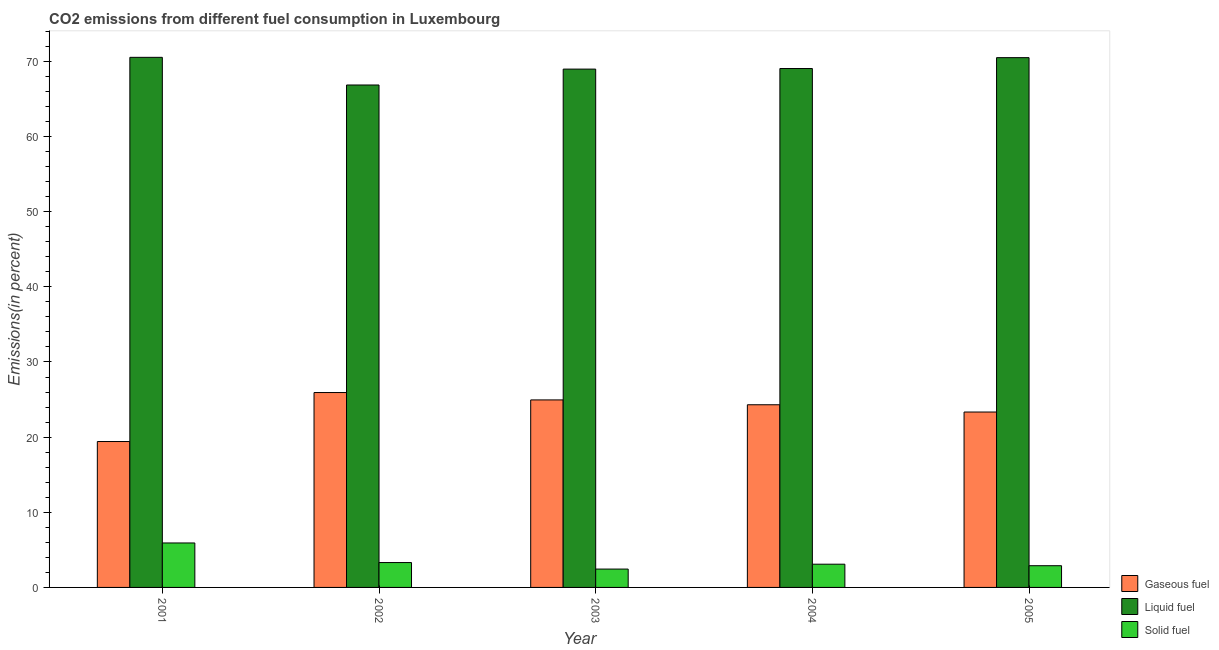Are the number of bars on each tick of the X-axis equal?
Provide a short and direct response. Yes. How many bars are there on the 4th tick from the left?
Offer a terse response. 3. What is the percentage of liquid fuel emission in 2002?
Your answer should be compact. 66.86. Across all years, what is the maximum percentage of solid fuel emission?
Provide a succinct answer. 5.92. Across all years, what is the minimum percentage of liquid fuel emission?
Ensure brevity in your answer.  66.86. In which year was the percentage of solid fuel emission minimum?
Your answer should be very brief. 2003. What is the total percentage of gaseous fuel emission in the graph?
Offer a terse response. 117.95. What is the difference between the percentage of liquid fuel emission in 2001 and that in 2004?
Your answer should be very brief. 1.49. What is the difference between the percentage of liquid fuel emission in 2003 and the percentage of gaseous fuel emission in 2005?
Offer a terse response. -1.52. What is the average percentage of gaseous fuel emission per year?
Keep it short and to the point. 23.59. In the year 2002, what is the difference between the percentage of gaseous fuel emission and percentage of liquid fuel emission?
Your answer should be very brief. 0. In how many years, is the percentage of solid fuel emission greater than 30 %?
Your response must be concise. 0. What is the ratio of the percentage of solid fuel emission in 2001 to that in 2002?
Offer a very short reply. 1.79. Is the difference between the percentage of gaseous fuel emission in 2002 and 2003 greater than the difference between the percentage of liquid fuel emission in 2002 and 2003?
Make the answer very short. No. What is the difference between the highest and the second highest percentage of liquid fuel emission?
Provide a short and direct response. 0.04. What is the difference between the highest and the lowest percentage of liquid fuel emission?
Keep it short and to the point. 3.68. What does the 2nd bar from the left in 2005 represents?
Provide a succinct answer. Liquid fuel. What does the 1st bar from the right in 2004 represents?
Offer a terse response. Solid fuel. How many bars are there?
Your answer should be compact. 15. Are all the bars in the graph horizontal?
Your response must be concise. No. How many years are there in the graph?
Your answer should be very brief. 5. What is the difference between two consecutive major ticks on the Y-axis?
Offer a very short reply. 10. Where does the legend appear in the graph?
Offer a very short reply. Bottom right. What is the title of the graph?
Provide a short and direct response. CO2 emissions from different fuel consumption in Luxembourg. Does "Machinery" appear as one of the legend labels in the graph?
Keep it short and to the point. No. What is the label or title of the X-axis?
Offer a terse response. Year. What is the label or title of the Y-axis?
Provide a succinct answer. Emissions(in percent). What is the Emissions(in percent) in Gaseous fuel in 2001?
Offer a very short reply. 19.42. What is the Emissions(in percent) of Liquid fuel in 2001?
Provide a succinct answer. 70.54. What is the Emissions(in percent) in Solid fuel in 2001?
Keep it short and to the point. 5.92. What is the Emissions(in percent) of Gaseous fuel in 2002?
Ensure brevity in your answer.  25.93. What is the Emissions(in percent) of Liquid fuel in 2002?
Provide a succinct answer. 66.86. What is the Emissions(in percent) of Solid fuel in 2002?
Offer a very short reply. 3.31. What is the Emissions(in percent) in Gaseous fuel in 2003?
Offer a terse response. 24.95. What is the Emissions(in percent) in Liquid fuel in 2003?
Offer a very short reply. 68.97. What is the Emissions(in percent) of Solid fuel in 2003?
Provide a short and direct response. 2.44. What is the Emissions(in percent) in Gaseous fuel in 2004?
Keep it short and to the point. 24.31. What is the Emissions(in percent) in Liquid fuel in 2004?
Offer a very short reply. 69.05. What is the Emissions(in percent) in Solid fuel in 2004?
Your response must be concise. 3.09. What is the Emissions(in percent) of Gaseous fuel in 2005?
Your response must be concise. 23.34. What is the Emissions(in percent) of Liquid fuel in 2005?
Provide a short and direct response. 70.5. What is the Emissions(in percent) of Solid fuel in 2005?
Your answer should be very brief. 2.89. Across all years, what is the maximum Emissions(in percent) of Gaseous fuel?
Keep it short and to the point. 25.93. Across all years, what is the maximum Emissions(in percent) in Liquid fuel?
Your answer should be compact. 70.54. Across all years, what is the maximum Emissions(in percent) of Solid fuel?
Ensure brevity in your answer.  5.92. Across all years, what is the minimum Emissions(in percent) in Gaseous fuel?
Offer a very short reply. 19.42. Across all years, what is the minimum Emissions(in percent) of Liquid fuel?
Make the answer very short. 66.86. Across all years, what is the minimum Emissions(in percent) of Solid fuel?
Give a very brief answer. 2.44. What is the total Emissions(in percent) in Gaseous fuel in the graph?
Offer a terse response. 117.95. What is the total Emissions(in percent) of Liquid fuel in the graph?
Keep it short and to the point. 345.93. What is the total Emissions(in percent) of Solid fuel in the graph?
Your answer should be compact. 17.65. What is the difference between the Emissions(in percent) in Gaseous fuel in 2001 and that in 2002?
Keep it short and to the point. -6.52. What is the difference between the Emissions(in percent) in Liquid fuel in 2001 and that in 2002?
Keep it short and to the point. 3.68. What is the difference between the Emissions(in percent) in Solid fuel in 2001 and that in 2002?
Make the answer very short. 2.61. What is the difference between the Emissions(in percent) of Gaseous fuel in 2001 and that in 2003?
Provide a short and direct response. -5.54. What is the difference between the Emissions(in percent) in Liquid fuel in 2001 and that in 2003?
Provide a short and direct response. 1.57. What is the difference between the Emissions(in percent) of Solid fuel in 2001 and that in 2003?
Give a very brief answer. 3.47. What is the difference between the Emissions(in percent) of Gaseous fuel in 2001 and that in 2004?
Keep it short and to the point. -4.89. What is the difference between the Emissions(in percent) of Liquid fuel in 2001 and that in 2004?
Make the answer very short. 1.49. What is the difference between the Emissions(in percent) in Solid fuel in 2001 and that in 2004?
Give a very brief answer. 2.83. What is the difference between the Emissions(in percent) in Gaseous fuel in 2001 and that in 2005?
Your answer should be very brief. -3.92. What is the difference between the Emissions(in percent) of Liquid fuel in 2001 and that in 2005?
Give a very brief answer. 0.04. What is the difference between the Emissions(in percent) in Solid fuel in 2001 and that in 2005?
Keep it short and to the point. 3.03. What is the difference between the Emissions(in percent) of Gaseous fuel in 2002 and that in 2003?
Provide a short and direct response. 0.98. What is the difference between the Emissions(in percent) of Liquid fuel in 2002 and that in 2003?
Provide a succinct answer. -2.11. What is the difference between the Emissions(in percent) of Solid fuel in 2002 and that in 2003?
Your answer should be compact. 0.87. What is the difference between the Emissions(in percent) of Gaseous fuel in 2002 and that in 2004?
Offer a terse response. 1.63. What is the difference between the Emissions(in percent) of Liquid fuel in 2002 and that in 2004?
Offer a very short reply. -2.19. What is the difference between the Emissions(in percent) of Solid fuel in 2002 and that in 2004?
Your response must be concise. 0.22. What is the difference between the Emissions(in percent) of Gaseous fuel in 2002 and that in 2005?
Provide a succinct answer. 2.59. What is the difference between the Emissions(in percent) in Liquid fuel in 2002 and that in 2005?
Ensure brevity in your answer.  -3.64. What is the difference between the Emissions(in percent) in Solid fuel in 2002 and that in 2005?
Provide a short and direct response. 0.42. What is the difference between the Emissions(in percent) in Gaseous fuel in 2003 and that in 2004?
Offer a terse response. 0.65. What is the difference between the Emissions(in percent) in Liquid fuel in 2003 and that in 2004?
Offer a terse response. -0.08. What is the difference between the Emissions(in percent) in Solid fuel in 2003 and that in 2004?
Your answer should be very brief. -0.65. What is the difference between the Emissions(in percent) of Gaseous fuel in 2003 and that in 2005?
Offer a terse response. 1.61. What is the difference between the Emissions(in percent) of Liquid fuel in 2003 and that in 2005?
Your answer should be compact. -1.52. What is the difference between the Emissions(in percent) in Solid fuel in 2003 and that in 2005?
Your answer should be compact. -0.45. What is the difference between the Emissions(in percent) of Gaseous fuel in 2004 and that in 2005?
Make the answer very short. 0.97. What is the difference between the Emissions(in percent) of Liquid fuel in 2004 and that in 2005?
Your response must be concise. -1.45. What is the difference between the Emissions(in percent) in Solid fuel in 2004 and that in 2005?
Your answer should be compact. 0.2. What is the difference between the Emissions(in percent) of Gaseous fuel in 2001 and the Emissions(in percent) of Liquid fuel in 2002?
Provide a short and direct response. -47.44. What is the difference between the Emissions(in percent) of Gaseous fuel in 2001 and the Emissions(in percent) of Solid fuel in 2002?
Make the answer very short. 16.11. What is the difference between the Emissions(in percent) in Liquid fuel in 2001 and the Emissions(in percent) in Solid fuel in 2002?
Offer a very short reply. 67.23. What is the difference between the Emissions(in percent) in Gaseous fuel in 2001 and the Emissions(in percent) in Liquid fuel in 2003?
Provide a succinct answer. -49.56. What is the difference between the Emissions(in percent) in Gaseous fuel in 2001 and the Emissions(in percent) in Solid fuel in 2003?
Give a very brief answer. 16.97. What is the difference between the Emissions(in percent) in Liquid fuel in 2001 and the Emissions(in percent) in Solid fuel in 2003?
Your answer should be compact. 68.1. What is the difference between the Emissions(in percent) of Gaseous fuel in 2001 and the Emissions(in percent) of Liquid fuel in 2004?
Ensure brevity in your answer.  -49.64. What is the difference between the Emissions(in percent) of Gaseous fuel in 2001 and the Emissions(in percent) of Solid fuel in 2004?
Your response must be concise. 16.33. What is the difference between the Emissions(in percent) of Liquid fuel in 2001 and the Emissions(in percent) of Solid fuel in 2004?
Provide a short and direct response. 67.45. What is the difference between the Emissions(in percent) in Gaseous fuel in 2001 and the Emissions(in percent) in Liquid fuel in 2005?
Give a very brief answer. -51.08. What is the difference between the Emissions(in percent) of Gaseous fuel in 2001 and the Emissions(in percent) of Solid fuel in 2005?
Ensure brevity in your answer.  16.53. What is the difference between the Emissions(in percent) in Liquid fuel in 2001 and the Emissions(in percent) in Solid fuel in 2005?
Make the answer very short. 67.65. What is the difference between the Emissions(in percent) of Gaseous fuel in 2002 and the Emissions(in percent) of Liquid fuel in 2003?
Your answer should be very brief. -43.04. What is the difference between the Emissions(in percent) in Gaseous fuel in 2002 and the Emissions(in percent) in Solid fuel in 2003?
Your answer should be compact. 23.49. What is the difference between the Emissions(in percent) of Liquid fuel in 2002 and the Emissions(in percent) of Solid fuel in 2003?
Offer a terse response. 64.42. What is the difference between the Emissions(in percent) of Gaseous fuel in 2002 and the Emissions(in percent) of Liquid fuel in 2004?
Provide a succinct answer. -43.12. What is the difference between the Emissions(in percent) of Gaseous fuel in 2002 and the Emissions(in percent) of Solid fuel in 2004?
Offer a very short reply. 22.84. What is the difference between the Emissions(in percent) in Liquid fuel in 2002 and the Emissions(in percent) in Solid fuel in 2004?
Give a very brief answer. 63.77. What is the difference between the Emissions(in percent) of Gaseous fuel in 2002 and the Emissions(in percent) of Liquid fuel in 2005?
Your answer should be compact. -44.56. What is the difference between the Emissions(in percent) of Gaseous fuel in 2002 and the Emissions(in percent) of Solid fuel in 2005?
Ensure brevity in your answer.  23.04. What is the difference between the Emissions(in percent) of Liquid fuel in 2002 and the Emissions(in percent) of Solid fuel in 2005?
Provide a short and direct response. 63.97. What is the difference between the Emissions(in percent) of Gaseous fuel in 2003 and the Emissions(in percent) of Liquid fuel in 2004?
Keep it short and to the point. -44.1. What is the difference between the Emissions(in percent) in Gaseous fuel in 2003 and the Emissions(in percent) in Solid fuel in 2004?
Your answer should be compact. 21.86. What is the difference between the Emissions(in percent) in Liquid fuel in 2003 and the Emissions(in percent) in Solid fuel in 2004?
Your response must be concise. 65.88. What is the difference between the Emissions(in percent) in Gaseous fuel in 2003 and the Emissions(in percent) in Liquid fuel in 2005?
Your answer should be very brief. -45.54. What is the difference between the Emissions(in percent) in Gaseous fuel in 2003 and the Emissions(in percent) in Solid fuel in 2005?
Your answer should be very brief. 22.06. What is the difference between the Emissions(in percent) of Liquid fuel in 2003 and the Emissions(in percent) of Solid fuel in 2005?
Keep it short and to the point. 66.08. What is the difference between the Emissions(in percent) of Gaseous fuel in 2004 and the Emissions(in percent) of Liquid fuel in 2005?
Your answer should be very brief. -46.19. What is the difference between the Emissions(in percent) of Gaseous fuel in 2004 and the Emissions(in percent) of Solid fuel in 2005?
Keep it short and to the point. 21.42. What is the difference between the Emissions(in percent) of Liquid fuel in 2004 and the Emissions(in percent) of Solid fuel in 2005?
Keep it short and to the point. 66.16. What is the average Emissions(in percent) of Gaseous fuel per year?
Ensure brevity in your answer.  23.59. What is the average Emissions(in percent) of Liquid fuel per year?
Your answer should be very brief. 69.19. What is the average Emissions(in percent) in Solid fuel per year?
Provide a succinct answer. 3.53. In the year 2001, what is the difference between the Emissions(in percent) in Gaseous fuel and Emissions(in percent) in Liquid fuel?
Keep it short and to the point. -51.12. In the year 2001, what is the difference between the Emissions(in percent) in Liquid fuel and Emissions(in percent) in Solid fuel?
Your answer should be very brief. 64.62. In the year 2002, what is the difference between the Emissions(in percent) in Gaseous fuel and Emissions(in percent) in Liquid fuel?
Ensure brevity in your answer.  -40.93. In the year 2002, what is the difference between the Emissions(in percent) in Gaseous fuel and Emissions(in percent) in Solid fuel?
Your answer should be very brief. 22.62. In the year 2002, what is the difference between the Emissions(in percent) of Liquid fuel and Emissions(in percent) of Solid fuel?
Offer a terse response. 63.55. In the year 2003, what is the difference between the Emissions(in percent) in Gaseous fuel and Emissions(in percent) in Liquid fuel?
Ensure brevity in your answer.  -44.02. In the year 2003, what is the difference between the Emissions(in percent) of Gaseous fuel and Emissions(in percent) of Solid fuel?
Offer a terse response. 22.51. In the year 2003, what is the difference between the Emissions(in percent) in Liquid fuel and Emissions(in percent) in Solid fuel?
Keep it short and to the point. 66.53. In the year 2004, what is the difference between the Emissions(in percent) of Gaseous fuel and Emissions(in percent) of Liquid fuel?
Ensure brevity in your answer.  -44.74. In the year 2004, what is the difference between the Emissions(in percent) in Gaseous fuel and Emissions(in percent) in Solid fuel?
Ensure brevity in your answer.  21.22. In the year 2004, what is the difference between the Emissions(in percent) in Liquid fuel and Emissions(in percent) in Solid fuel?
Your answer should be very brief. 65.96. In the year 2005, what is the difference between the Emissions(in percent) of Gaseous fuel and Emissions(in percent) of Liquid fuel?
Make the answer very short. -47.16. In the year 2005, what is the difference between the Emissions(in percent) in Gaseous fuel and Emissions(in percent) in Solid fuel?
Provide a succinct answer. 20.45. In the year 2005, what is the difference between the Emissions(in percent) in Liquid fuel and Emissions(in percent) in Solid fuel?
Offer a terse response. 67.61. What is the ratio of the Emissions(in percent) in Gaseous fuel in 2001 to that in 2002?
Offer a very short reply. 0.75. What is the ratio of the Emissions(in percent) of Liquid fuel in 2001 to that in 2002?
Ensure brevity in your answer.  1.05. What is the ratio of the Emissions(in percent) of Solid fuel in 2001 to that in 2002?
Keep it short and to the point. 1.79. What is the ratio of the Emissions(in percent) in Gaseous fuel in 2001 to that in 2003?
Make the answer very short. 0.78. What is the ratio of the Emissions(in percent) in Liquid fuel in 2001 to that in 2003?
Give a very brief answer. 1.02. What is the ratio of the Emissions(in percent) in Solid fuel in 2001 to that in 2003?
Make the answer very short. 2.42. What is the ratio of the Emissions(in percent) in Gaseous fuel in 2001 to that in 2004?
Your response must be concise. 0.8. What is the ratio of the Emissions(in percent) in Liquid fuel in 2001 to that in 2004?
Keep it short and to the point. 1.02. What is the ratio of the Emissions(in percent) in Solid fuel in 2001 to that in 2004?
Provide a short and direct response. 1.91. What is the ratio of the Emissions(in percent) of Gaseous fuel in 2001 to that in 2005?
Provide a succinct answer. 0.83. What is the ratio of the Emissions(in percent) in Solid fuel in 2001 to that in 2005?
Make the answer very short. 2.05. What is the ratio of the Emissions(in percent) of Gaseous fuel in 2002 to that in 2003?
Your answer should be compact. 1.04. What is the ratio of the Emissions(in percent) of Liquid fuel in 2002 to that in 2003?
Ensure brevity in your answer.  0.97. What is the ratio of the Emissions(in percent) in Solid fuel in 2002 to that in 2003?
Offer a very short reply. 1.35. What is the ratio of the Emissions(in percent) of Gaseous fuel in 2002 to that in 2004?
Make the answer very short. 1.07. What is the ratio of the Emissions(in percent) of Liquid fuel in 2002 to that in 2004?
Your answer should be very brief. 0.97. What is the ratio of the Emissions(in percent) in Solid fuel in 2002 to that in 2004?
Ensure brevity in your answer.  1.07. What is the ratio of the Emissions(in percent) of Liquid fuel in 2002 to that in 2005?
Provide a short and direct response. 0.95. What is the ratio of the Emissions(in percent) of Solid fuel in 2002 to that in 2005?
Ensure brevity in your answer.  1.15. What is the ratio of the Emissions(in percent) in Gaseous fuel in 2003 to that in 2004?
Keep it short and to the point. 1.03. What is the ratio of the Emissions(in percent) of Liquid fuel in 2003 to that in 2004?
Give a very brief answer. 1. What is the ratio of the Emissions(in percent) in Solid fuel in 2003 to that in 2004?
Offer a very short reply. 0.79. What is the ratio of the Emissions(in percent) of Gaseous fuel in 2003 to that in 2005?
Provide a succinct answer. 1.07. What is the ratio of the Emissions(in percent) of Liquid fuel in 2003 to that in 2005?
Keep it short and to the point. 0.98. What is the ratio of the Emissions(in percent) of Solid fuel in 2003 to that in 2005?
Give a very brief answer. 0.85. What is the ratio of the Emissions(in percent) of Gaseous fuel in 2004 to that in 2005?
Provide a short and direct response. 1.04. What is the ratio of the Emissions(in percent) of Liquid fuel in 2004 to that in 2005?
Give a very brief answer. 0.98. What is the ratio of the Emissions(in percent) in Solid fuel in 2004 to that in 2005?
Provide a short and direct response. 1.07. What is the difference between the highest and the second highest Emissions(in percent) in Gaseous fuel?
Provide a short and direct response. 0.98. What is the difference between the highest and the second highest Emissions(in percent) of Liquid fuel?
Offer a terse response. 0.04. What is the difference between the highest and the second highest Emissions(in percent) in Solid fuel?
Offer a very short reply. 2.61. What is the difference between the highest and the lowest Emissions(in percent) in Gaseous fuel?
Ensure brevity in your answer.  6.52. What is the difference between the highest and the lowest Emissions(in percent) in Liquid fuel?
Your response must be concise. 3.68. What is the difference between the highest and the lowest Emissions(in percent) of Solid fuel?
Offer a very short reply. 3.47. 